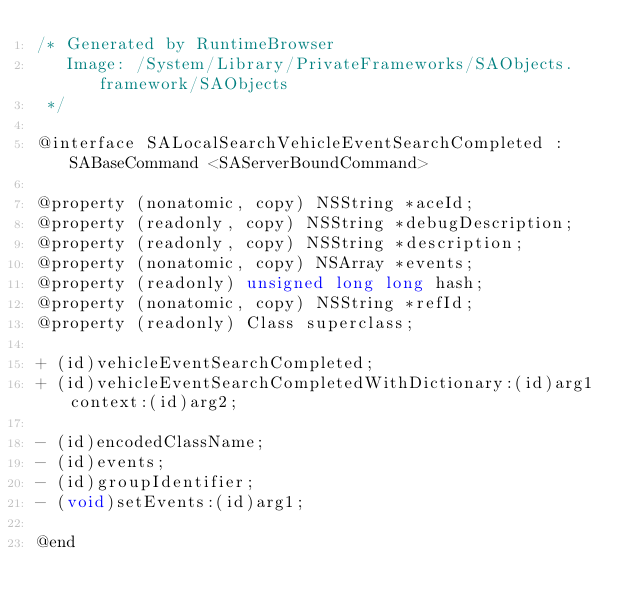<code> <loc_0><loc_0><loc_500><loc_500><_C_>/* Generated by RuntimeBrowser
   Image: /System/Library/PrivateFrameworks/SAObjects.framework/SAObjects
 */

@interface SALocalSearchVehicleEventSearchCompleted : SABaseCommand <SAServerBoundCommand>

@property (nonatomic, copy) NSString *aceId;
@property (readonly, copy) NSString *debugDescription;
@property (readonly, copy) NSString *description;
@property (nonatomic, copy) NSArray *events;
@property (readonly) unsigned long long hash;
@property (nonatomic, copy) NSString *refId;
@property (readonly) Class superclass;

+ (id)vehicleEventSearchCompleted;
+ (id)vehicleEventSearchCompletedWithDictionary:(id)arg1 context:(id)arg2;

- (id)encodedClassName;
- (id)events;
- (id)groupIdentifier;
- (void)setEvents:(id)arg1;

@end
</code> 